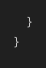<code> <loc_0><loc_0><loc_500><loc_500><_Java_>    }
}


</code> 